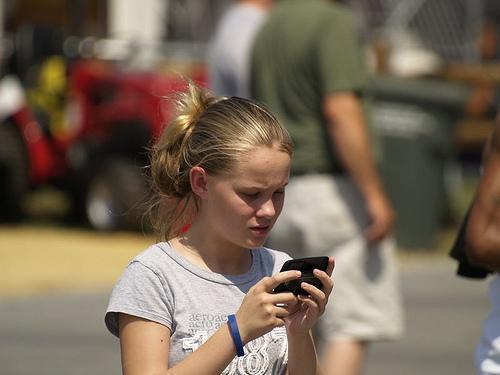What phone feature is she using?
Answer the question by selecting the correct answer among the 4 following choices and explain your choice with a short sentence. The answer should be formatted with the following format: `Answer: choice
Rationale: rationale.`
Options: Flip, slide, open, zoom. Answer: slide.
Rationale: The girl is holding the phone horizontally and it appears there is a piece that fits over the other. this style of phone was able to slide one piece over the other and that is what it would be called. 